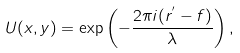Convert formula to latex. <formula><loc_0><loc_0><loc_500><loc_500>U ( x , y ) = \exp \left ( - \frac { 2 \pi i ( r ^ { ^ { \prime } } - f ) } { \lambda } \right ) ,</formula> 